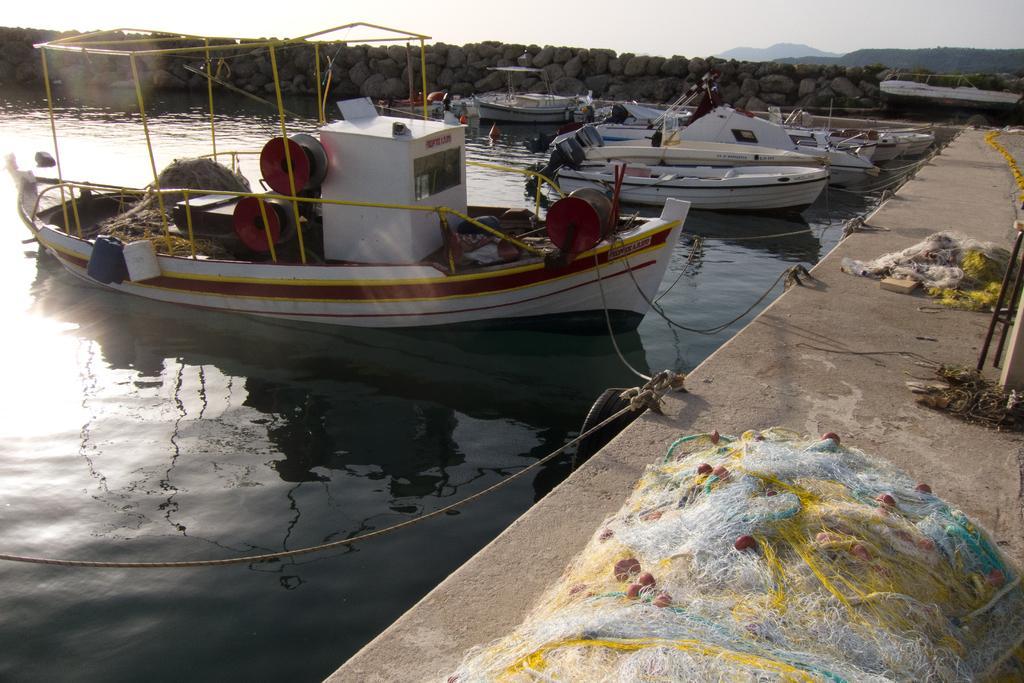Could you give a brief overview of what you see in this image? In this image there are boats on water. To the right side of the image there is a platform on which there are nets. In the background of the image there are stones. 